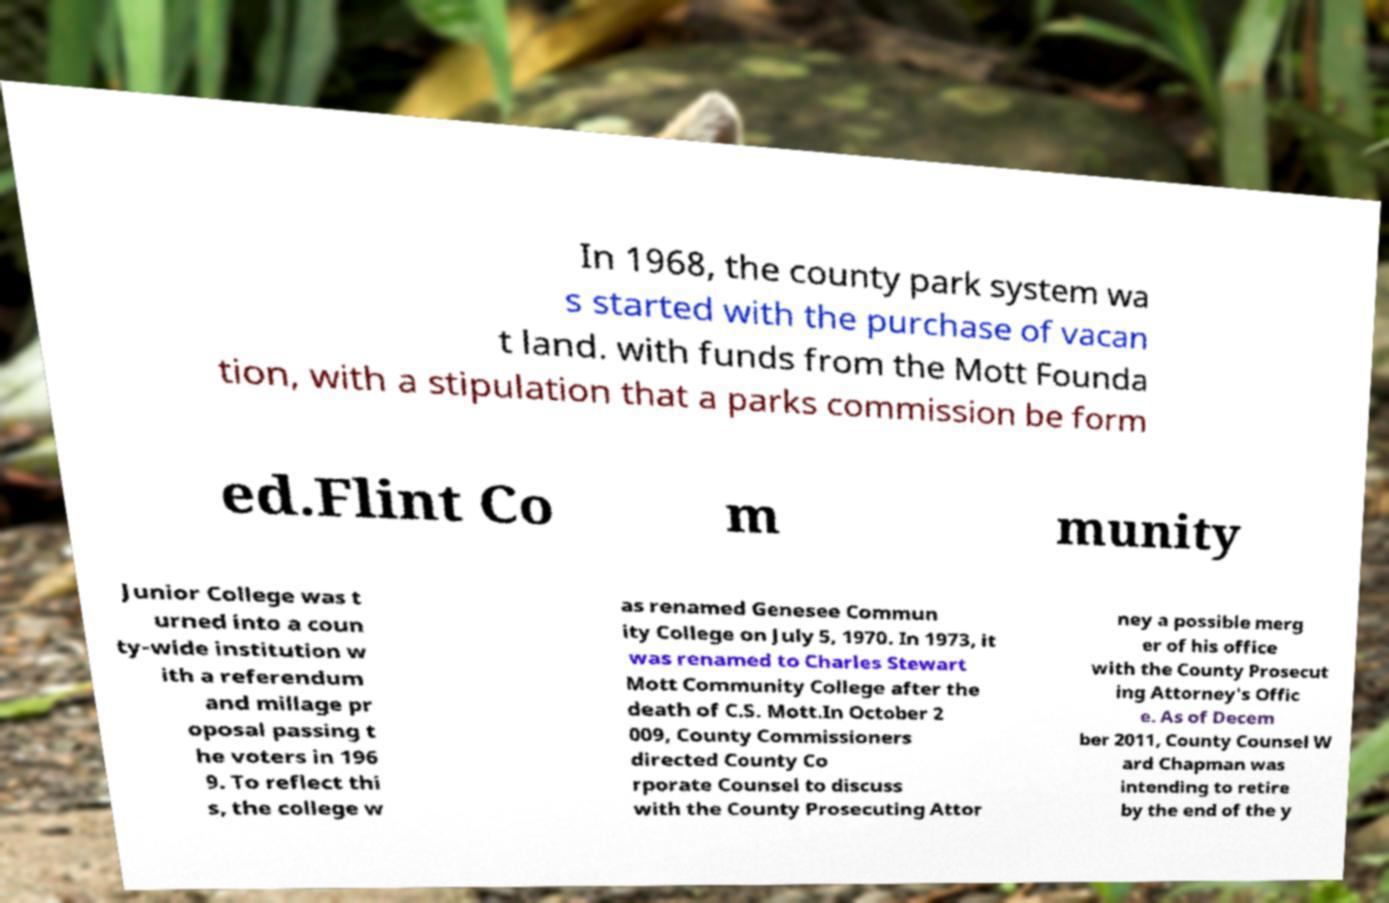Could you assist in decoding the text presented in this image and type it out clearly? In 1968, the county park system wa s started with the purchase of vacan t land. with funds from the Mott Founda tion, with a stipulation that a parks commission be form ed.Flint Co m munity Junior College was t urned into a coun ty-wide institution w ith a referendum and millage pr oposal passing t he voters in 196 9. To reflect thi s, the college w as renamed Genesee Commun ity College on July 5, 1970. In 1973, it was renamed to Charles Stewart Mott Community College after the death of C.S. Mott.In October 2 009, County Commissioners directed County Co rporate Counsel to discuss with the County Prosecuting Attor ney a possible merg er of his office with the County Prosecut ing Attorney's Offic e. As of Decem ber 2011, County Counsel W ard Chapman was intending to retire by the end of the y 